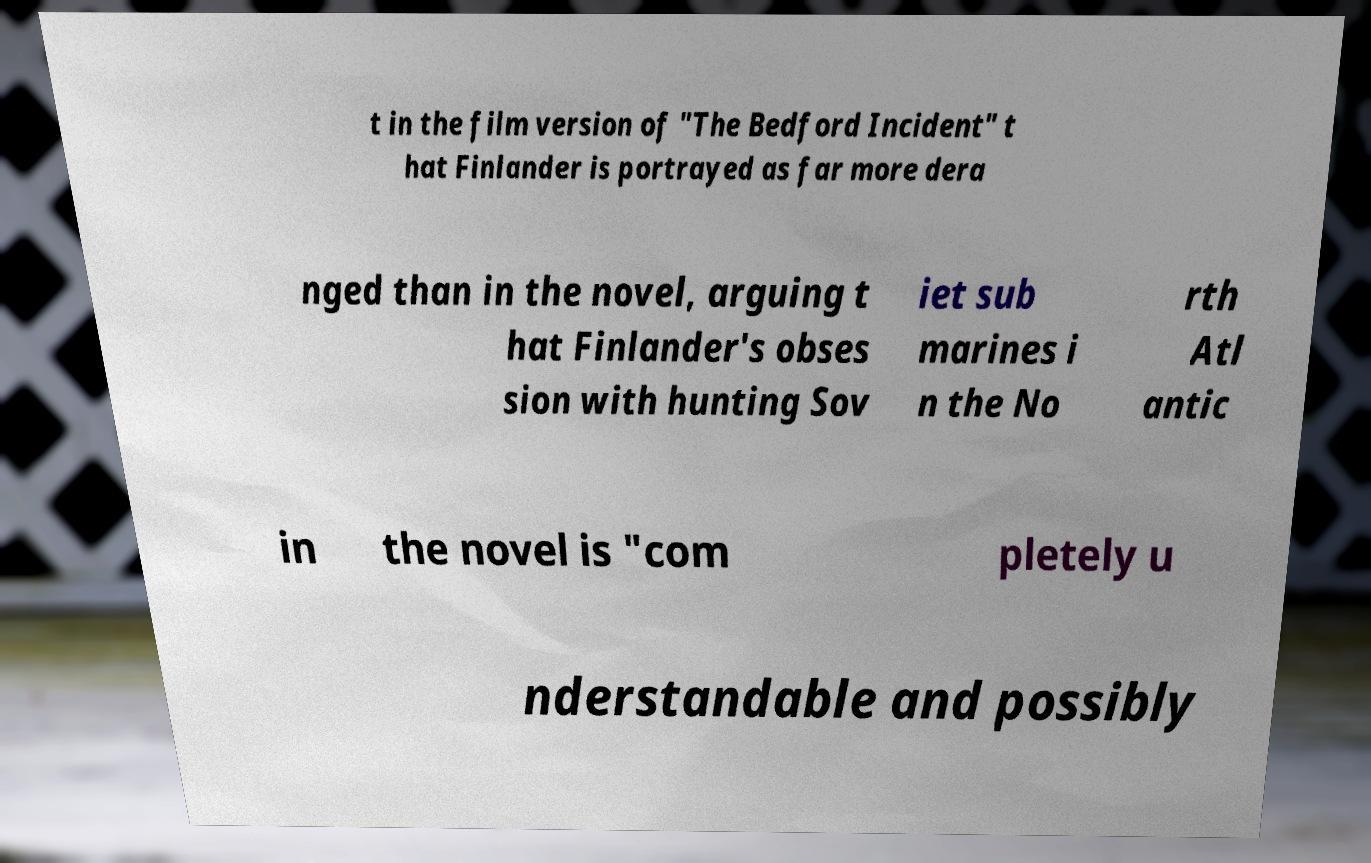Can you read and provide the text displayed in the image?This photo seems to have some interesting text. Can you extract and type it out for me? t in the film version of "The Bedford Incident" t hat Finlander is portrayed as far more dera nged than in the novel, arguing t hat Finlander's obses sion with hunting Sov iet sub marines i n the No rth Atl antic in the novel is "com pletely u nderstandable and possibly 